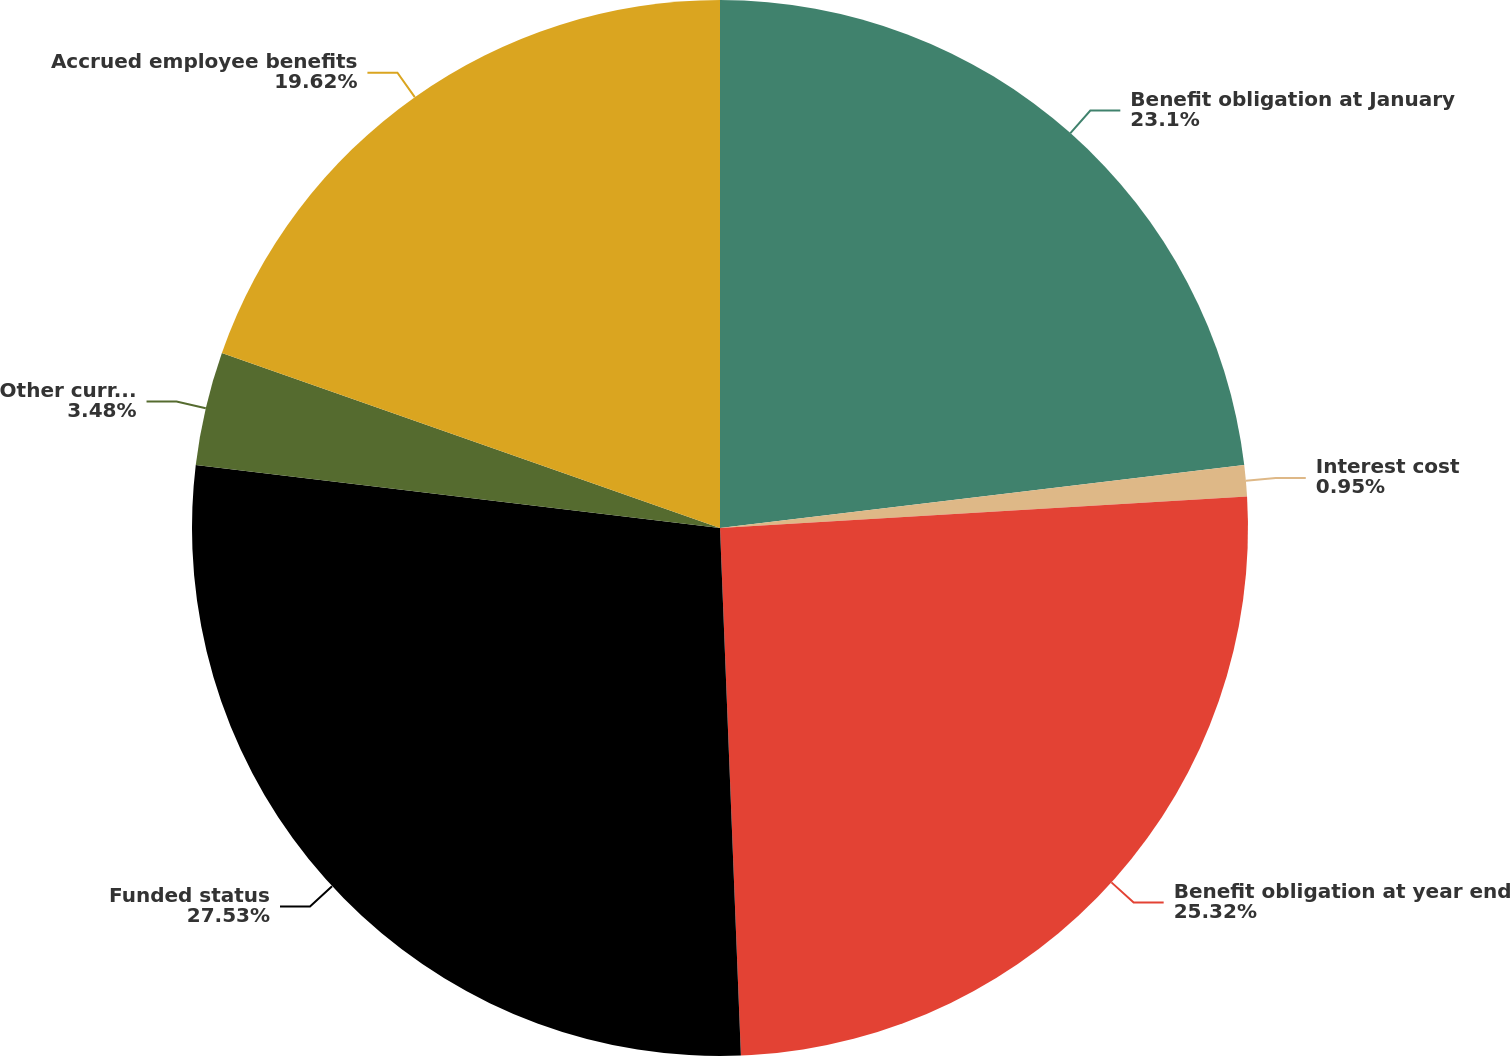Convert chart. <chart><loc_0><loc_0><loc_500><loc_500><pie_chart><fcel>Benefit obligation at January<fcel>Interest cost<fcel>Benefit obligation at year end<fcel>Funded status<fcel>Other current liabilities<fcel>Accrued employee benefits<nl><fcel>23.1%<fcel>0.95%<fcel>25.32%<fcel>27.53%<fcel>3.48%<fcel>19.62%<nl></chart> 